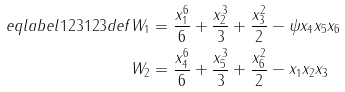Convert formula to latex. <formula><loc_0><loc_0><loc_500><loc_500>\ e q l a b e l { 1 2 3 1 2 3 d e f } W _ { 1 } & = \frac { x _ { 1 } ^ { 6 } } 6 + \frac { x _ { 2 } ^ { 3 } } 3 + \frac { x _ { 3 } ^ { 2 } } 2 - \psi x _ { 4 } x _ { 5 } x _ { 6 } \\ W _ { 2 } & = \frac { x _ { 4 } ^ { 6 } } 6 + \frac { x _ { 5 } ^ { 3 } } 3 + \frac { x _ { 6 } ^ { 2 } } 2 - x _ { 1 } x _ { 2 } x _ { 3 }</formula> 